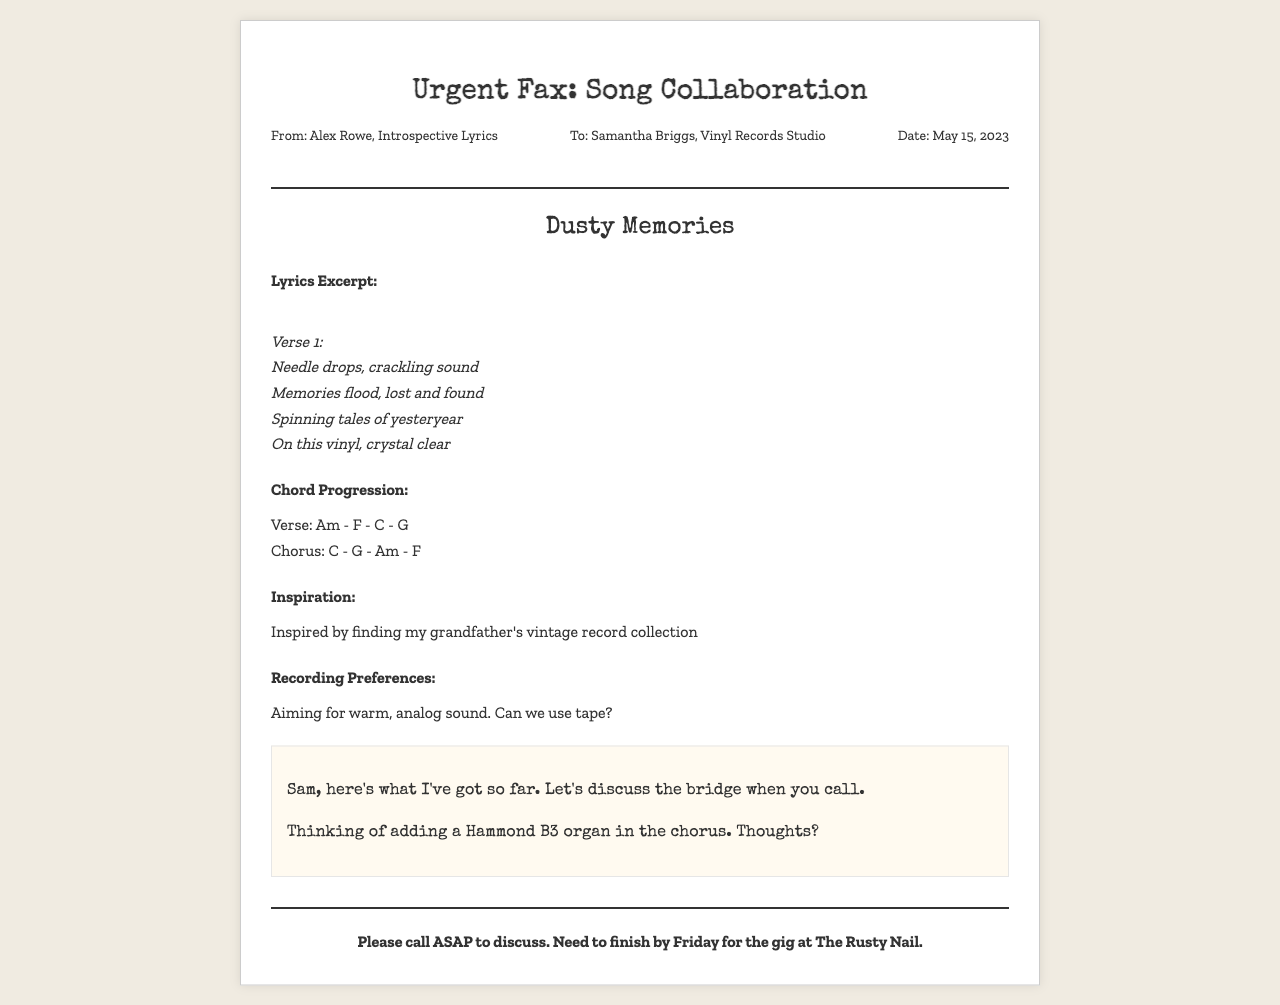what is the title of the song? The title of the song is mentioned in the document under the song title section.
Answer: Dusty Memories who is the fax from? The document states the sender at the top, under the "From" section.
Answer: Alex Rowe what is the chord progression for the verse? The chord progression for the verse is listed in the corresponding section of the document.
Answer: Am - F - C - G what inspired the lyrics of the song? Inspiration is explained in a section dedicated to it in the document.
Answer: Finding my grandfather's vintage record collection what is the date of the fax? The date is included in the metadata section at the top of the document.
Answer: May 15, 2023 what recording technique is proposed? The document mentions a specific recording preference in the recording preferences section.
Answer: Tape what instrument is being considered for the chorus? The handwritten section discusses potential additions to the chorus.
Answer: Hammond B3 organ who is the fax addressed to? The recipient's name is specified at the beginning of the document.
Answer: Samantha Briggs by when does the collaboration need to be completed? The urgency of the completion date is noted in the footer of the document.
Answer: Friday 